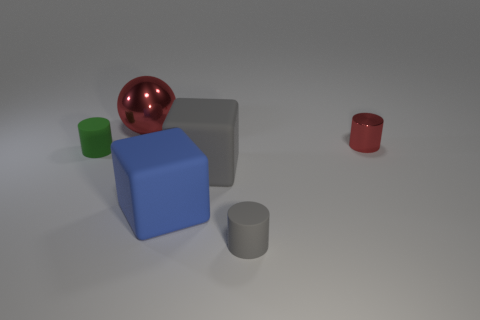How do the shadows in the image inform us about the light source? The shadows in the image are soft and extend to the left of the objects, indicating that the primary light source is located to the right and possibly above the scene. The diffuse nature of the shadows suggests that the light source is not overly harsh or direct, which creates a more even and gentle illumination on the objects. 